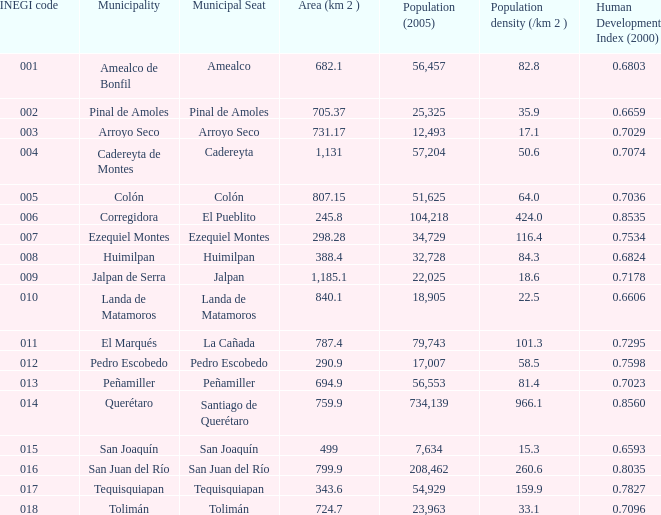6593 human development index (2000)? 15.0. 